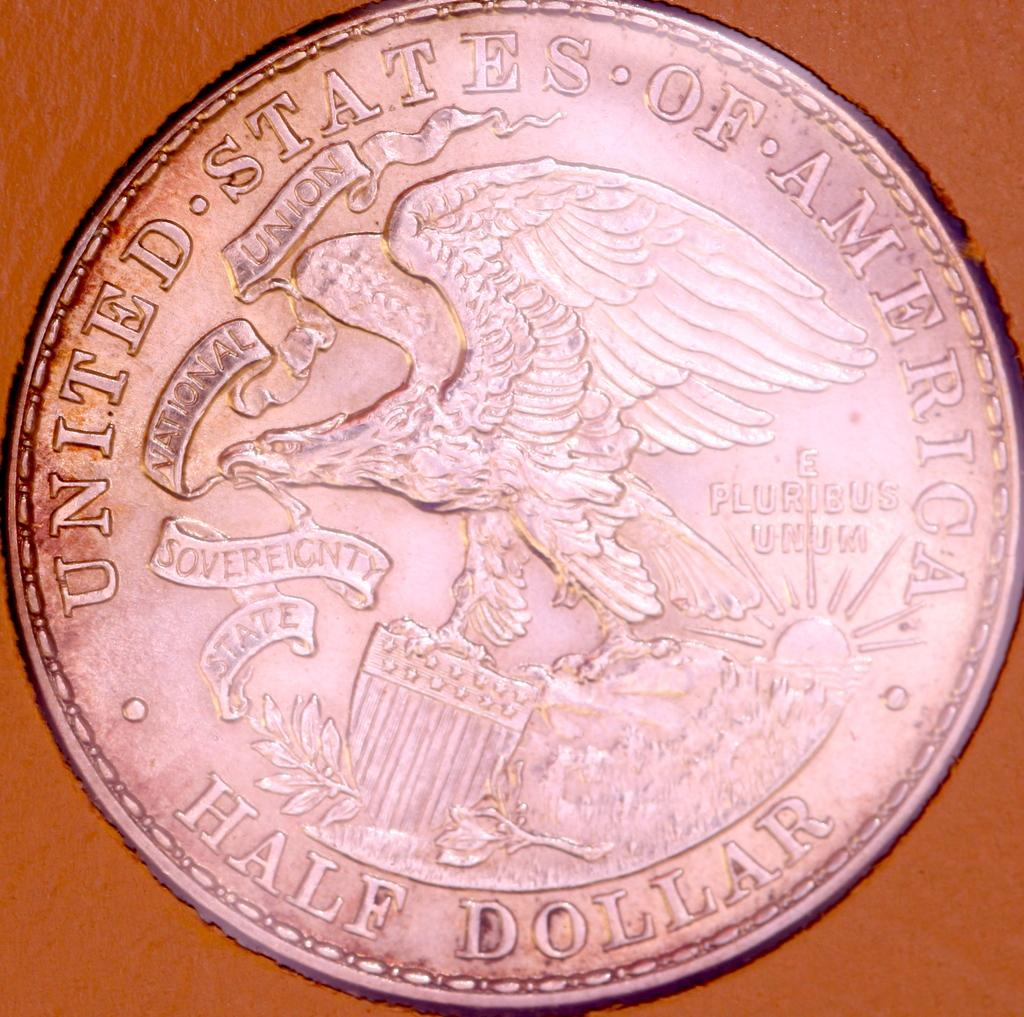<image>
Render a clear and concise summary of the photo. a half dollar that says 'united states of america' at the top of it 